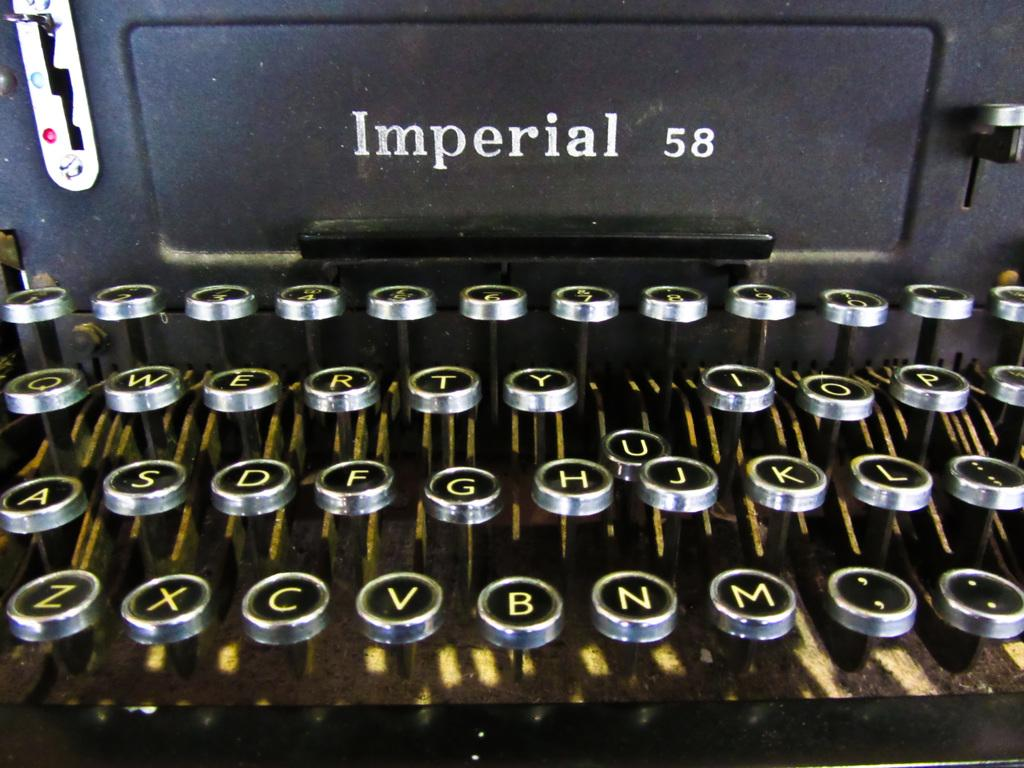<image>
Provide a brief description of the given image. An old Imperial 58 typewriter with some of the keys showing such as Z, X, C, V and B showing. 